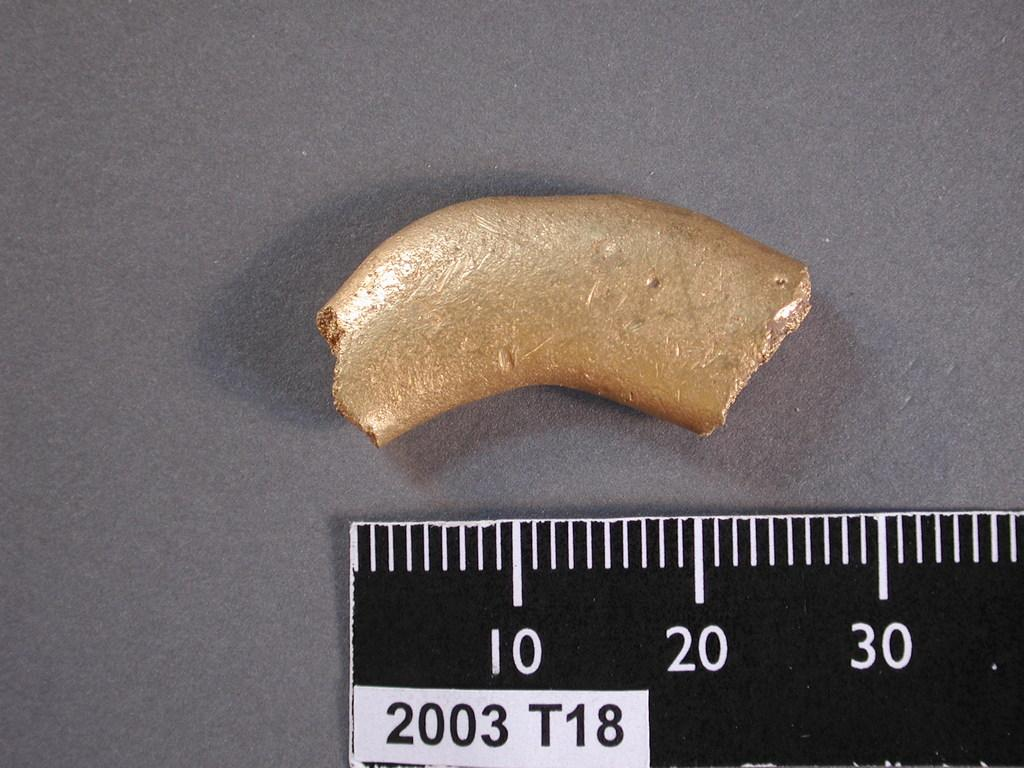Provide a one-sentence caption for the provided image. A black and white ruler with 2003 T18 on it. 